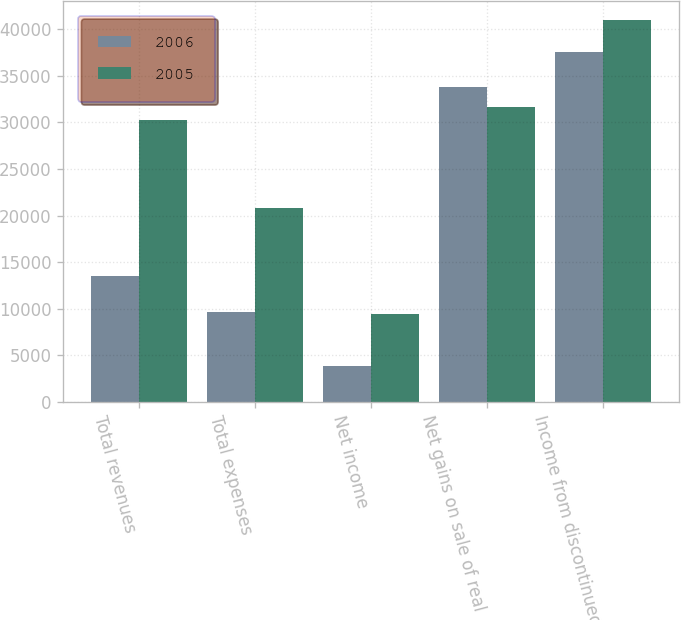Convert chart to OTSL. <chart><loc_0><loc_0><loc_500><loc_500><stacked_bar_chart><ecel><fcel>Total revenues<fcel>Total expenses<fcel>Net income<fcel>Net gains on sale of real<fcel>Income from discontinued<nl><fcel>2006<fcel>13522<fcel>9696<fcel>3826<fcel>33769<fcel>37595<nl><fcel>2005<fcel>30221<fcel>20815<fcel>9406<fcel>31614<fcel>41020<nl></chart> 